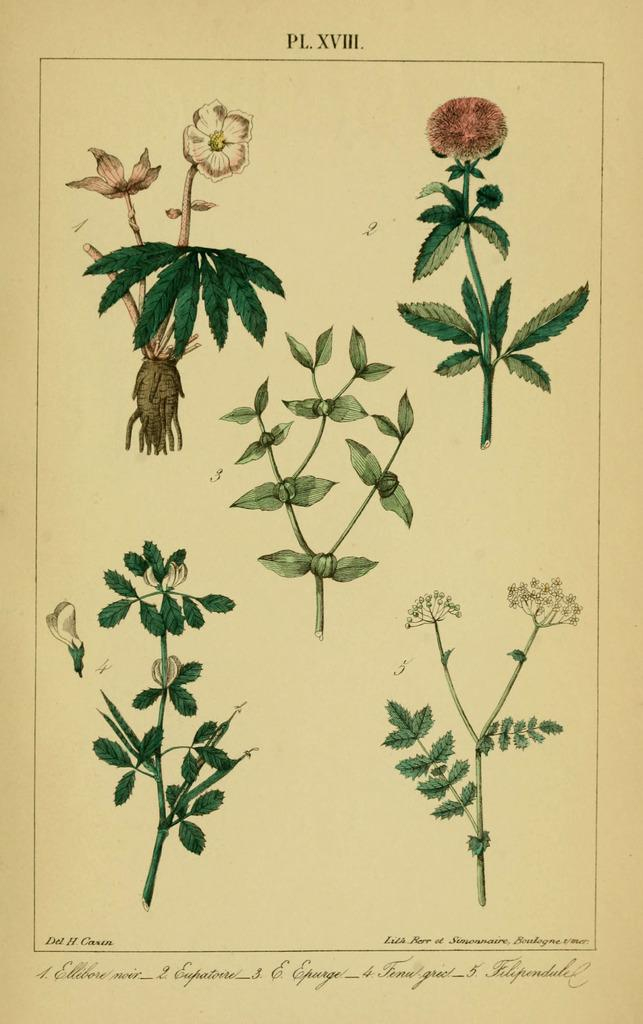What type of artwork is depicted in the image? There is a painting of flowers and a painting of plants in the image. What can be found in addition to the paintings in the image? There is writing on the image. What type of popcorn is being served in the image? There is no popcorn present in the image; it features paintings of flowers and plants, along with writing. What type of verse can be found in the image? There is no verse present in the image; it only contains paintings of flowers and plants, as well as writing. 